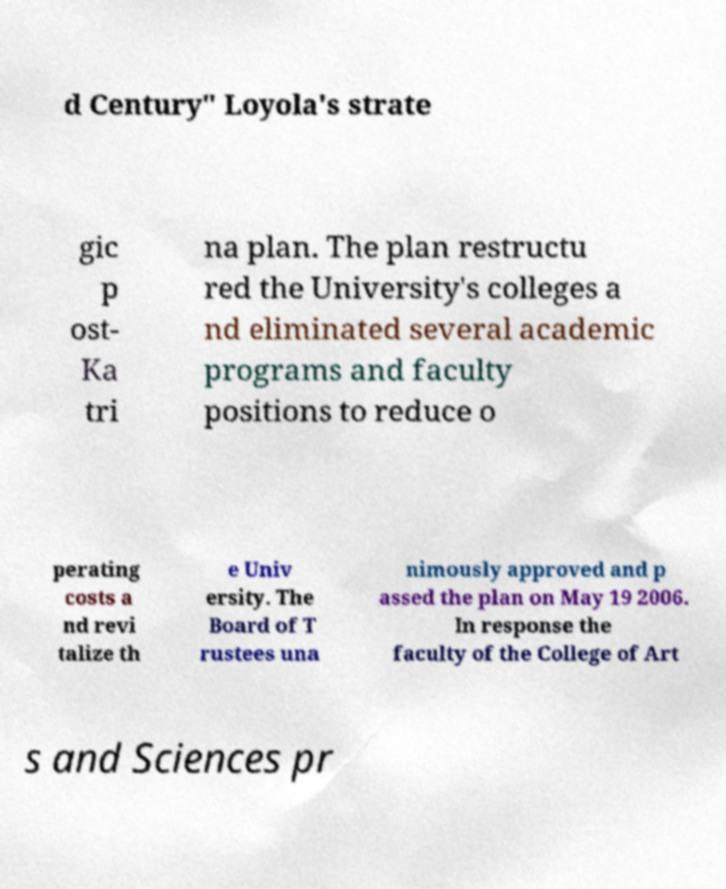Could you assist in decoding the text presented in this image and type it out clearly? d Century" Loyola's strate gic p ost- Ka tri na plan. The plan restructu red the University's colleges a nd eliminated several academic programs and faculty positions to reduce o perating costs a nd revi talize th e Univ ersity. The Board of T rustees una nimously approved and p assed the plan on May 19 2006. In response the faculty of the College of Art s and Sciences pr 